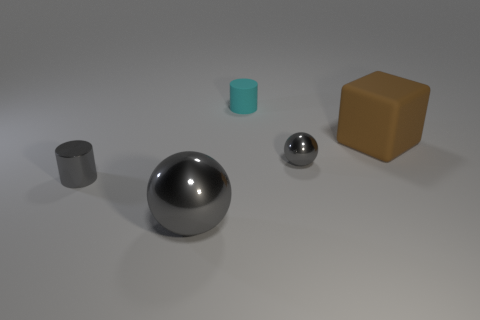The big sphere is what color?
Give a very brief answer. Gray. Are there any gray metallic things to the right of the small cylinder in front of the cyan matte object?
Offer a terse response. Yes. What is the shape of the large thing that is in front of the shiny ball that is behind the metal cylinder?
Your response must be concise. Sphere. Are there fewer tiny green metal blocks than tiny cyan objects?
Offer a very short reply. Yes. Is the material of the brown cube the same as the small gray cylinder?
Your response must be concise. No. There is a small thing that is both to the right of the shiny cylinder and in front of the large brown rubber block; what color is it?
Provide a succinct answer. Gray. Are there any spheres that have the same size as the cyan cylinder?
Offer a terse response. Yes. There is a matte object on the left side of the gray object to the right of the big gray metallic thing; what is its size?
Offer a very short reply. Small. Is the number of objects that are behind the small matte object less than the number of tiny green cylinders?
Ensure brevity in your answer.  No. Is the metallic cylinder the same color as the large metal sphere?
Offer a very short reply. Yes. 